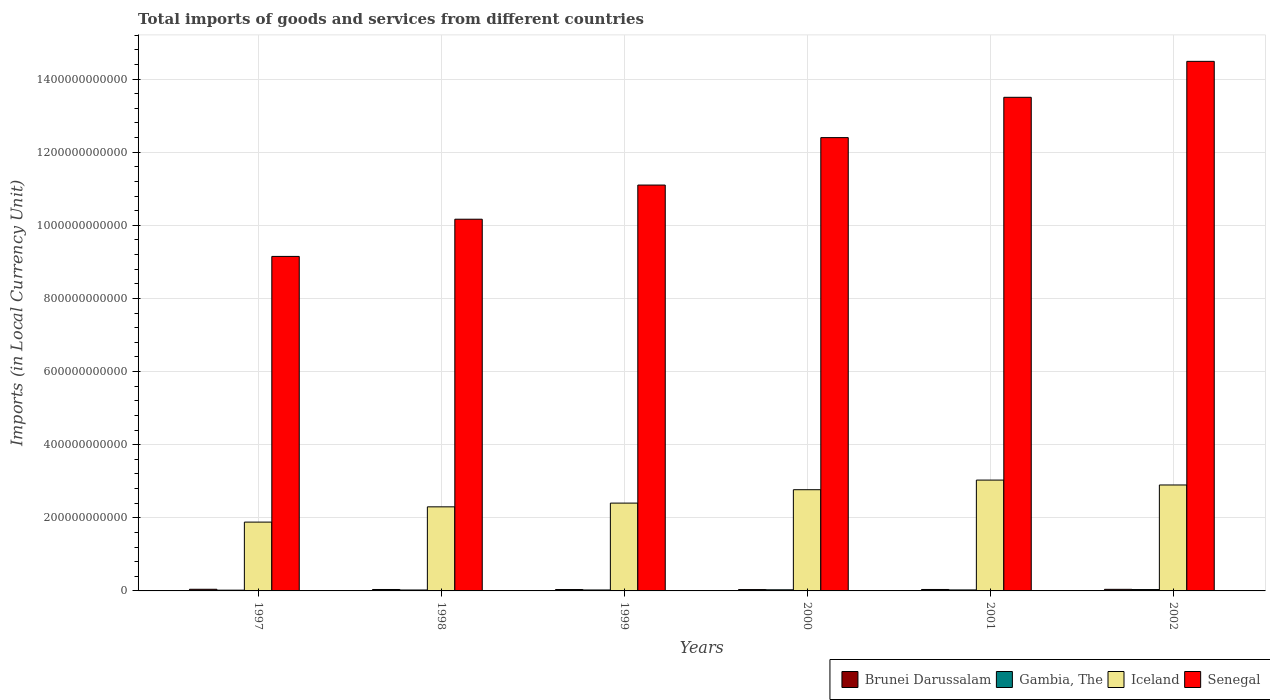How many groups of bars are there?
Your response must be concise. 6. Are the number of bars on each tick of the X-axis equal?
Make the answer very short. Yes. How many bars are there on the 6th tick from the right?
Your response must be concise. 4. In how many cases, is the number of bars for a given year not equal to the number of legend labels?
Your answer should be very brief. 0. What is the Amount of goods and services imports in Iceland in 2001?
Provide a short and direct response. 3.03e+11. Across all years, what is the maximum Amount of goods and services imports in Gambia, The?
Give a very brief answer. 3.74e+09. Across all years, what is the minimum Amount of goods and services imports in Iceland?
Keep it short and to the point. 1.88e+11. In which year was the Amount of goods and services imports in Senegal minimum?
Make the answer very short. 1997. What is the total Amount of goods and services imports in Senegal in the graph?
Your answer should be compact. 7.08e+12. What is the difference between the Amount of goods and services imports in Gambia, The in 2000 and that in 2001?
Your answer should be very brief. 3.52e+08. What is the difference between the Amount of goods and services imports in Brunei Darussalam in 2002 and the Amount of goods and services imports in Senegal in 1999?
Keep it short and to the point. -1.11e+12. What is the average Amount of goods and services imports in Gambia, The per year?
Make the answer very short. 2.79e+09. In the year 2000, what is the difference between the Amount of goods and services imports in Iceland and Amount of goods and services imports in Brunei Darussalam?
Give a very brief answer. 2.73e+11. In how many years, is the Amount of goods and services imports in Brunei Darussalam greater than 600000000000 LCU?
Your response must be concise. 0. What is the ratio of the Amount of goods and services imports in Gambia, The in 2000 to that in 2002?
Your answer should be very brief. 0.82. Is the Amount of goods and services imports in Senegal in 1999 less than that in 2001?
Your answer should be compact. Yes. What is the difference between the highest and the second highest Amount of goods and services imports in Iceland?
Give a very brief answer. 1.34e+1. What is the difference between the highest and the lowest Amount of goods and services imports in Senegal?
Your answer should be compact. 5.34e+11. In how many years, is the Amount of goods and services imports in Gambia, The greater than the average Amount of goods and services imports in Gambia, The taken over all years?
Provide a short and direct response. 2. Is the sum of the Amount of goods and services imports in Brunei Darussalam in 1997 and 2002 greater than the maximum Amount of goods and services imports in Gambia, The across all years?
Keep it short and to the point. Yes. Is it the case that in every year, the sum of the Amount of goods and services imports in Gambia, The and Amount of goods and services imports in Iceland is greater than the sum of Amount of goods and services imports in Senegal and Amount of goods and services imports in Brunei Darussalam?
Provide a succinct answer. Yes. What does the 2nd bar from the left in 1997 represents?
Give a very brief answer. Gambia, The. What does the 4th bar from the right in 1998 represents?
Keep it short and to the point. Brunei Darussalam. Is it the case that in every year, the sum of the Amount of goods and services imports in Senegal and Amount of goods and services imports in Iceland is greater than the Amount of goods and services imports in Brunei Darussalam?
Your answer should be compact. Yes. Are all the bars in the graph horizontal?
Keep it short and to the point. No. How many years are there in the graph?
Make the answer very short. 6. What is the difference between two consecutive major ticks on the Y-axis?
Make the answer very short. 2.00e+11. Are the values on the major ticks of Y-axis written in scientific E-notation?
Keep it short and to the point. No. Does the graph contain any zero values?
Ensure brevity in your answer.  No. Does the graph contain grids?
Offer a very short reply. Yes. Where does the legend appear in the graph?
Make the answer very short. Bottom right. How are the legend labels stacked?
Make the answer very short. Horizontal. What is the title of the graph?
Provide a short and direct response. Total imports of goods and services from different countries. What is the label or title of the Y-axis?
Ensure brevity in your answer.  Imports (in Local Currency Unit). What is the Imports (in Local Currency Unit) of Brunei Darussalam in 1997?
Give a very brief answer. 4.51e+09. What is the Imports (in Local Currency Unit) in Gambia, The in 1997?
Your answer should be very brief. 2.08e+09. What is the Imports (in Local Currency Unit) of Iceland in 1997?
Offer a terse response. 1.88e+11. What is the Imports (in Local Currency Unit) in Senegal in 1997?
Ensure brevity in your answer.  9.15e+11. What is the Imports (in Local Currency Unit) in Brunei Darussalam in 1998?
Offer a terse response. 3.89e+09. What is the Imports (in Local Currency Unit) of Gambia, The in 1998?
Keep it short and to the point. 2.55e+09. What is the Imports (in Local Currency Unit) of Iceland in 1998?
Provide a succinct answer. 2.30e+11. What is the Imports (in Local Currency Unit) of Senegal in 1998?
Ensure brevity in your answer.  1.02e+12. What is the Imports (in Local Currency Unit) of Brunei Darussalam in 1999?
Your response must be concise. 3.77e+09. What is the Imports (in Local Currency Unit) of Gambia, The in 1999?
Your answer should be very brief. 2.60e+09. What is the Imports (in Local Currency Unit) in Iceland in 1999?
Offer a terse response. 2.40e+11. What is the Imports (in Local Currency Unit) of Senegal in 1999?
Make the answer very short. 1.11e+12. What is the Imports (in Local Currency Unit) of Brunei Darussalam in 2000?
Ensure brevity in your answer.  3.71e+09. What is the Imports (in Local Currency Unit) of Gambia, The in 2000?
Your answer should be compact. 3.06e+09. What is the Imports (in Local Currency Unit) of Iceland in 2000?
Offer a very short reply. 2.77e+11. What is the Imports (in Local Currency Unit) in Senegal in 2000?
Offer a terse response. 1.24e+12. What is the Imports (in Local Currency Unit) of Brunei Darussalam in 2001?
Your answer should be compact. 3.93e+09. What is the Imports (in Local Currency Unit) of Gambia, The in 2001?
Your answer should be very brief. 2.71e+09. What is the Imports (in Local Currency Unit) in Iceland in 2001?
Ensure brevity in your answer.  3.03e+11. What is the Imports (in Local Currency Unit) in Senegal in 2001?
Offer a terse response. 1.35e+12. What is the Imports (in Local Currency Unit) of Brunei Darussalam in 2002?
Offer a very short reply. 4.36e+09. What is the Imports (in Local Currency Unit) in Gambia, The in 2002?
Your response must be concise. 3.74e+09. What is the Imports (in Local Currency Unit) of Iceland in 2002?
Your response must be concise. 2.90e+11. What is the Imports (in Local Currency Unit) of Senegal in 2002?
Provide a succinct answer. 1.45e+12. Across all years, what is the maximum Imports (in Local Currency Unit) of Brunei Darussalam?
Offer a terse response. 4.51e+09. Across all years, what is the maximum Imports (in Local Currency Unit) of Gambia, The?
Give a very brief answer. 3.74e+09. Across all years, what is the maximum Imports (in Local Currency Unit) in Iceland?
Provide a short and direct response. 3.03e+11. Across all years, what is the maximum Imports (in Local Currency Unit) of Senegal?
Provide a short and direct response. 1.45e+12. Across all years, what is the minimum Imports (in Local Currency Unit) in Brunei Darussalam?
Give a very brief answer. 3.71e+09. Across all years, what is the minimum Imports (in Local Currency Unit) in Gambia, The?
Give a very brief answer. 2.08e+09. Across all years, what is the minimum Imports (in Local Currency Unit) of Iceland?
Offer a very short reply. 1.88e+11. Across all years, what is the minimum Imports (in Local Currency Unit) of Senegal?
Provide a succinct answer. 9.15e+11. What is the total Imports (in Local Currency Unit) of Brunei Darussalam in the graph?
Provide a short and direct response. 2.42e+1. What is the total Imports (in Local Currency Unit) of Gambia, The in the graph?
Keep it short and to the point. 1.67e+1. What is the total Imports (in Local Currency Unit) of Iceland in the graph?
Your answer should be very brief. 1.53e+12. What is the total Imports (in Local Currency Unit) in Senegal in the graph?
Ensure brevity in your answer.  7.08e+12. What is the difference between the Imports (in Local Currency Unit) in Brunei Darussalam in 1997 and that in 1998?
Offer a very short reply. 6.22e+08. What is the difference between the Imports (in Local Currency Unit) of Gambia, The in 1997 and that in 1998?
Ensure brevity in your answer.  -4.74e+08. What is the difference between the Imports (in Local Currency Unit) of Iceland in 1997 and that in 1998?
Make the answer very short. -4.18e+1. What is the difference between the Imports (in Local Currency Unit) in Senegal in 1997 and that in 1998?
Provide a succinct answer. -1.02e+11. What is the difference between the Imports (in Local Currency Unit) in Brunei Darussalam in 1997 and that in 1999?
Give a very brief answer. 7.40e+08. What is the difference between the Imports (in Local Currency Unit) in Gambia, The in 1997 and that in 1999?
Provide a short and direct response. -5.20e+08. What is the difference between the Imports (in Local Currency Unit) in Iceland in 1997 and that in 1999?
Offer a terse response. -5.20e+1. What is the difference between the Imports (in Local Currency Unit) in Senegal in 1997 and that in 1999?
Offer a very short reply. -1.95e+11. What is the difference between the Imports (in Local Currency Unit) of Brunei Darussalam in 1997 and that in 2000?
Your answer should be very brief. 8.08e+08. What is the difference between the Imports (in Local Currency Unit) in Gambia, The in 1997 and that in 2000?
Your answer should be compact. -9.79e+08. What is the difference between the Imports (in Local Currency Unit) of Iceland in 1997 and that in 2000?
Your answer should be compact. -8.86e+1. What is the difference between the Imports (in Local Currency Unit) of Senegal in 1997 and that in 2000?
Ensure brevity in your answer.  -3.25e+11. What is the difference between the Imports (in Local Currency Unit) of Brunei Darussalam in 1997 and that in 2001?
Provide a short and direct response. 5.81e+08. What is the difference between the Imports (in Local Currency Unit) in Gambia, The in 1997 and that in 2001?
Provide a short and direct response. -6.27e+08. What is the difference between the Imports (in Local Currency Unit) of Iceland in 1997 and that in 2001?
Provide a succinct answer. -1.15e+11. What is the difference between the Imports (in Local Currency Unit) of Senegal in 1997 and that in 2001?
Your answer should be compact. -4.35e+11. What is the difference between the Imports (in Local Currency Unit) in Brunei Darussalam in 1997 and that in 2002?
Your answer should be compact. 1.59e+08. What is the difference between the Imports (in Local Currency Unit) of Gambia, The in 1997 and that in 2002?
Give a very brief answer. -1.66e+09. What is the difference between the Imports (in Local Currency Unit) in Iceland in 1997 and that in 2002?
Give a very brief answer. -1.02e+11. What is the difference between the Imports (in Local Currency Unit) in Senegal in 1997 and that in 2002?
Ensure brevity in your answer.  -5.34e+11. What is the difference between the Imports (in Local Currency Unit) of Brunei Darussalam in 1998 and that in 1999?
Make the answer very short. 1.18e+08. What is the difference between the Imports (in Local Currency Unit) in Gambia, The in 1998 and that in 1999?
Keep it short and to the point. -4.63e+07. What is the difference between the Imports (in Local Currency Unit) of Iceland in 1998 and that in 1999?
Offer a very short reply. -1.02e+1. What is the difference between the Imports (in Local Currency Unit) in Senegal in 1998 and that in 1999?
Give a very brief answer. -9.34e+1. What is the difference between the Imports (in Local Currency Unit) of Brunei Darussalam in 1998 and that in 2000?
Make the answer very short. 1.86e+08. What is the difference between the Imports (in Local Currency Unit) of Gambia, The in 1998 and that in 2000?
Your response must be concise. -5.05e+08. What is the difference between the Imports (in Local Currency Unit) in Iceland in 1998 and that in 2000?
Provide a short and direct response. -4.68e+1. What is the difference between the Imports (in Local Currency Unit) of Senegal in 1998 and that in 2000?
Offer a very short reply. -2.23e+11. What is the difference between the Imports (in Local Currency Unit) of Brunei Darussalam in 1998 and that in 2001?
Give a very brief answer. -4.13e+07. What is the difference between the Imports (in Local Currency Unit) of Gambia, The in 1998 and that in 2001?
Keep it short and to the point. -1.53e+08. What is the difference between the Imports (in Local Currency Unit) of Iceland in 1998 and that in 2001?
Give a very brief answer. -7.32e+1. What is the difference between the Imports (in Local Currency Unit) of Senegal in 1998 and that in 2001?
Give a very brief answer. -3.33e+11. What is the difference between the Imports (in Local Currency Unit) in Brunei Darussalam in 1998 and that in 2002?
Provide a succinct answer. -4.63e+08. What is the difference between the Imports (in Local Currency Unit) in Gambia, The in 1998 and that in 2002?
Offer a very short reply. -1.19e+09. What is the difference between the Imports (in Local Currency Unit) of Iceland in 1998 and that in 2002?
Your answer should be very brief. -5.98e+1. What is the difference between the Imports (in Local Currency Unit) in Senegal in 1998 and that in 2002?
Ensure brevity in your answer.  -4.32e+11. What is the difference between the Imports (in Local Currency Unit) in Brunei Darussalam in 1999 and that in 2000?
Give a very brief answer. 6.83e+07. What is the difference between the Imports (in Local Currency Unit) in Gambia, The in 1999 and that in 2000?
Your response must be concise. -4.59e+08. What is the difference between the Imports (in Local Currency Unit) in Iceland in 1999 and that in 2000?
Your answer should be very brief. -3.66e+1. What is the difference between the Imports (in Local Currency Unit) in Senegal in 1999 and that in 2000?
Give a very brief answer. -1.30e+11. What is the difference between the Imports (in Local Currency Unit) of Brunei Darussalam in 1999 and that in 2001?
Give a very brief answer. -1.59e+08. What is the difference between the Imports (in Local Currency Unit) in Gambia, The in 1999 and that in 2001?
Make the answer very short. -1.07e+08. What is the difference between the Imports (in Local Currency Unit) in Iceland in 1999 and that in 2001?
Offer a very short reply. -6.30e+1. What is the difference between the Imports (in Local Currency Unit) in Senegal in 1999 and that in 2001?
Your answer should be very brief. -2.40e+11. What is the difference between the Imports (in Local Currency Unit) of Brunei Darussalam in 1999 and that in 2002?
Make the answer very short. -5.81e+08. What is the difference between the Imports (in Local Currency Unit) in Gambia, The in 1999 and that in 2002?
Offer a very short reply. -1.14e+09. What is the difference between the Imports (in Local Currency Unit) in Iceland in 1999 and that in 2002?
Your answer should be compact. -4.95e+1. What is the difference between the Imports (in Local Currency Unit) in Senegal in 1999 and that in 2002?
Give a very brief answer. -3.38e+11. What is the difference between the Imports (in Local Currency Unit) of Brunei Darussalam in 2000 and that in 2001?
Your response must be concise. -2.28e+08. What is the difference between the Imports (in Local Currency Unit) of Gambia, The in 2000 and that in 2001?
Your response must be concise. 3.52e+08. What is the difference between the Imports (in Local Currency Unit) in Iceland in 2000 and that in 2001?
Your answer should be compact. -2.64e+1. What is the difference between the Imports (in Local Currency Unit) of Senegal in 2000 and that in 2001?
Your answer should be very brief. -1.10e+11. What is the difference between the Imports (in Local Currency Unit) in Brunei Darussalam in 2000 and that in 2002?
Give a very brief answer. -6.50e+08. What is the difference between the Imports (in Local Currency Unit) in Gambia, The in 2000 and that in 2002?
Give a very brief answer. -6.82e+08. What is the difference between the Imports (in Local Currency Unit) in Iceland in 2000 and that in 2002?
Offer a terse response. -1.29e+1. What is the difference between the Imports (in Local Currency Unit) in Senegal in 2000 and that in 2002?
Your response must be concise. -2.09e+11. What is the difference between the Imports (in Local Currency Unit) of Brunei Darussalam in 2001 and that in 2002?
Your answer should be very brief. -4.22e+08. What is the difference between the Imports (in Local Currency Unit) in Gambia, The in 2001 and that in 2002?
Ensure brevity in your answer.  -1.03e+09. What is the difference between the Imports (in Local Currency Unit) in Iceland in 2001 and that in 2002?
Your response must be concise. 1.34e+1. What is the difference between the Imports (in Local Currency Unit) in Senegal in 2001 and that in 2002?
Provide a succinct answer. -9.83e+1. What is the difference between the Imports (in Local Currency Unit) in Brunei Darussalam in 1997 and the Imports (in Local Currency Unit) in Gambia, The in 1998?
Offer a terse response. 1.96e+09. What is the difference between the Imports (in Local Currency Unit) of Brunei Darussalam in 1997 and the Imports (in Local Currency Unit) of Iceland in 1998?
Your answer should be very brief. -2.25e+11. What is the difference between the Imports (in Local Currency Unit) in Brunei Darussalam in 1997 and the Imports (in Local Currency Unit) in Senegal in 1998?
Make the answer very short. -1.01e+12. What is the difference between the Imports (in Local Currency Unit) in Gambia, The in 1997 and the Imports (in Local Currency Unit) in Iceland in 1998?
Provide a succinct answer. -2.28e+11. What is the difference between the Imports (in Local Currency Unit) in Gambia, The in 1997 and the Imports (in Local Currency Unit) in Senegal in 1998?
Offer a terse response. -1.01e+12. What is the difference between the Imports (in Local Currency Unit) in Iceland in 1997 and the Imports (in Local Currency Unit) in Senegal in 1998?
Provide a succinct answer. -8.29e+11. What is the difference between the Imports (in Local Currency Unit) of Brunei Darussalam in 1997 and the Imports (in Local Currency Unit) of Gambia, The in 1999?
Keep it short and to the point. 1.91e+09. What is the difference between the Imports (in Local Currency Unit) of Brunei Darussalam in 1997 and the Imports (in Local Currency Unit) of Iceland in 1999?
Keep it short and to the point. -2.36e+11. What is the difference between the Imports (in Local Currency Unit) of Brunei Darussalam in 1997 and the Imports (in Local Currency Unit) of Senegal in 1999?
Make the answer very short. -1.11e+12. What is the difference between the Imports (in Local Currency Unit) in Gambia, The in 1997 and the Imports (in Local Currency Unit) in Iceland in 1999?
Ensure brevity in your answer.  -2.38e+11. What is the difference between the Imports (in Local Currency Unit) of Gambia, The in 1997 and the Imports (in Local Currency Unit) of Senegal in 1999?
Ensure brevity in your answer.  -1.11e+12. What is the difference between the Imports (in Local Currency Unit) of Iceland in 1997 and the Imports (in Local Currency Unit) of Senegal in 1999?
Make the answer very short. -9.22e+11. What is the difference between the Imports (in Local Currency Unit) in Brunei Darussalam in 1997 and the Imports (in Local Currency Unit) in Gambia, The in 2000?
Ensure brevity in your answer.  1.45e+09. What is the difference between the Imports (in Local Currency Unit) in Brunei Darussalam in 1997 and the Imports (in Local Currency Unit) in Iceland in 2000?
Ensure brevity in your answer.  -2.72e+11. What is the difference between the Imports (in Local Currency Unit) in Brunei Darussalam in 1997 and the Imports (in Local Currency Unit) in Senegal in 2000?
Make the answer very short. -1.24e+12. What is the difference between the Imports (in Local Currency Unit) in Gambia, The in 1997 and the Imports (in Local Currency Unit) in Iceland in 2000?
Keep it short and to the point. -2.75e+11. What is the difference between the Imports (in Local Currency Unit) in Gambia, The in 1997 and the Imports (in Local Currency Unit) in Senegal in 2000?
Give a very brief answer. -1.24e+12. What is the difference between the Imports (in Local Currency Unit) in Iceland in 1997 and the Imports (in Local Currency Unit) in Senegal in 2000?
Your response must be concise. -1.05e+12. What is the difference between the Imports (in Local Currency Unit) in Brunei Darussalam in 1997 and the Imports (in Local Currency Unit) in Gambia, The in 2001?
Make the answer very short. 1.81e+09. What is the difference between the Imports (in Local Currency Unit) in Brunei Darussalam in 1997 and the Imports (in Local Currency Unit) in Iceland in 2001?
Make the answer very short. -2.99e+11. What is the difference between the Imports (in Local Currency Unit) of Brunei Darussalam in 1997 and the Imports (in Local Currency Unit) of Senegal in 2001?
Make the answer very short. -1.35e+12. What is the difference between the Imports (in Local Currency Unit) of Gambia, The in 1997 and the Imports (in Local Currency Unit) of Iceland in 2001?
Ensure brevity in your answer.  -3.01e+11. What is the difference between the Imports (in Local Currency Unit) of Gambia, The in 1997 and the Imports (in Local Currency Unit) of Senegal in 2001?
Your answer should be compact. -1.35e+12. What is the difference between the Imports (in Local Currency Unit) of Iceland in 1997 and the Imports (in Local Currency Unit) of Senegal in 2001?
Provide a short and direct response. -1.16e+12. What is the difference between the Imports (in Local Currency Unit) in Brunei Darussalam in 1997 and the Imports (in Local Currency Unit) in Gambia, The in 2002?
Provide a short and direct response. 7.73e+08. What is the difference between the Imports (in Local Currency Unit) of Brunei Darussalam in 1997 and the Imports (in Local Currency Unit) of Iceland in 2002?
Provide a short and direct response. -2.85e+11. What is the difference between the Imports (in Local Currency Unit) in Brunei Darussalam in 1997 and the Imports (in Local Currency Unit) in Senegal in 2002?
Ensure brevity in your answer.  -1.44e+12. What is the difference between the Imports (in Local Currency Unit) of Gambia, The in 1997 and the Imports (in Local Currency Unit) of Iceland in 2002?
Provide a succinct answer. -2.88e+11. What is the difference between the Imports (in Local Currency Unit) of Gambia, The in 1997 and the Imports (in Local Currency Unit) of Senegal in 2002?
Your answer should be compact. -1.45e+12. What is the difference between the Imports (in Local Currency Unit) of Iceland in 1997 and the Imports (in Local Currency Unit) of Senegal in 2002?
Provide a short and direct response. -1.26e+12. What is the difference between the Imports (in Local Currency Unit) of Brunei Darussalam in 1998 and the Imports (in Local Currency Unit) of Gambia, The in 1999?
Keep it short and to the point. 1.29e+09. What is the difference between the Imports (in Local Currency Unit) of Brunei Darussalam in 1998 and the Imports (in Local Currency Unit) of Iceland in 1999?
Keep it short and to the point. -2.36e+11. What is the difference between the Imports (in Local Currency Unit) of Brunei Darussalam in 1998 and the Imports (in Local Currency Unit) of Senegal in 1999?
Make the answer very short. -1.11e+12. What is the difference between the Imports (in Local Currency Unit) of Gambia, The in 1998 and the Imports (in Local Currency Unit) of Iceland in 1999?
Give a very brief answer. -2.38e+11. What is the difference between the Imports (in Local Currency Unit) in Gambia, The in 1998 and the Imports (in Local Currency Unit) in Senegal in 1999?
Your response must be concise. -1.11e+12. What is the difference between the Imports (in Local Currency Unit) of Iceland in 1998 and the Imports (in Local Currency Unit) of Senegal in 1999?
Your answer should be compact. -8.80e+11. What is the difference between the Imports (in Local Currency Unit) in Brunei Darussalam in 1998 and the Imports (in Local Currency Unit) in Gambia, The in 2000?
Provide a succinct answer. 8.32e+08. What is the difference between the Imports (in Local Currency Unit) of Brunei Darussalam in 1998 and the Imports (in Local Currency Unit) of Iceland in 2000?
Offer a terse response. -2.73e+11. What is the difference between the Imports (in Local Currency Unit) of Brunei Darussalam in 1998 and the Imports (in Local Currency Unit) of Senegal in 2000?
Offer a terse response. -1.24e+12. What is the difference between the Imports (in Local Currency Unit) of Gambia, The in 1998 and the Imports (in Local Currency Unit) of Iceland in 2000?
Your answer should be very brief. -2.74e+11. What is the difference between the Imports (in Local Currency Unit) of Gambia, The in 1998 and the Imports (in Local Currency Unit) of Senegal in 2000?
Provide a short and direct response. -1.24e+12. What is the difference between the Imports (in Local Currency Unit) of Iceland in 1998 and the Imports (in Local Currency Unit) of Senegal in 2000?
Your answer should be compact. -1.01e+12. What is the difference between the Imports (in Local Currency Unit) of Brunei Darussalam in 1998 and the Imports (in Local Currency Unit) of Gambia, The in 2001?
Your response must be concise. 1.18e+09. What is the difference between the Imports (in Local Currency Unit) in Brunei Darussalam in 1998 and the Imports (in Local Currency Unit) in Iceland in 2001?
Offer a terse response. -2.99e+11. What is the difference between the Imports (in Local Currency Unit) in Brunei Darussalam in 1998 and the Imports (in Local Currency Unit) in Senegal in 2001?
Offer a terse response. -1.35e+12. What is the difference between the Imports (in Local Currency Unit) of Gambia, The in 1998 and the Imports (in Local Currency Unit) of Iceland in 2001?
Make the answer very short. -3.01e+11. What is the difference between the Imports (in Local Currency Unit) of Gambia, The in 1998 and the Imports (in Local Currency Unit) of Senegal in 2001?
Your answer should be very brief. -1.35e+12. What is the difference between the Imports (in Local Currency Unit) of Iceland in 1998 and the Imports (in Local Currency Unit) of Senegal in 2001?
Ensure brevity in your answer.  -1.12e+12. What is the difference between the Imports (in Local Currency Unit) in Brunei Darussalam in 1998 and the Imports (in Local Currency Unit) in Gambia, The in 2002?
Your response must be concise. 1.51e+08. What is the difference between the Imports (in Local Currency Unit) of Brunei Darussalam in 1998 and the Imports (in Local Currency Unit) of Iceland in 2002?
Offer a terse response. -2.86e+11. What is the difference between the Imports (in Local Currency Unit) in Brunei Darussalam in 1998 and the Imports (in Local Currency Unit) in Senegal in 2002?
Offer a terse response. -1.44e+12. What is the difference between the Imports (in Local Currency Unit) in Gambia, The in 1998 and the Imports (in Local Currency Unit) in Iceland in 2002?
Offer a very short reply. -2.87e+11. What is the difference between the Imports (in Local Currency Unit) in Gambia, The in 1998 and the Imports (in Local Currency Unit) in Senegal in 2002?
Your response must be concise. -1.45e+12. What is the difference between the Imports (in Local Currency Unit) in Iceland in 1998 and the Imports (in Local Currency Unit) in Senegal in 2002?
Keep it short and to the point. -1.22e+12. What is the difference between the Imports (in Local Currency Unit) in Brunei Darussalam in 1999 and the Imports (in Local Currency Unit) in Gambia, The in 2000?
Offer a very short reply. 7.14e+08. What is the difference between the Imports (in Local Currency Unit) in Brunei Darussalam in 1999 and the Imports (in Local Currency Unit) in Iceland in 2000?
Provide a short and direct response. -2.73e+11. What is the difference between the Imports (in Local Currency Unit) in Brunei Darussalam in 1999 and the Imports (in Local Currency Unit) in Senegal in 2000?
Keep it short and to the point. -1.24e+12. What is the difference between the Imports (in Local Currency Unit) in Gambia, The in 1999 and the Imports (in Local Currency Unit) in Iceland in 2000?
Make the answer very short. -2.74e+11. What is the difference between the Imports (in Local Currency Unit) in Gambia, The in 1999 and the Imports (in Local Currency Unit) in Senegal in 2000?
Keep it short and to the point. -1.24e+12. What is the difference between the Imports (in Local Currency Unit) in Iceland in 1999 and the Imports (in Local Currency Unit) in Senegal in 2000?
Keep it short and to the point. -1.00e+12. What is the difference between the Imports (in Local Currency Unit) of Brunei Darussalam in 1999 and the Imports (in Local Currency Unit) of Gambia, The in 2001?
Offer a terse response. 1.07e+09. What is the difference between the Imports (in Local Currency Unit) in Brunei Darussalam in 1999 and the Imports (in Local Currency Unit) in Iceland in 2001?
Your answer should be very brief. -2.99e+11. What is the difference between the Imports (in Local Currency Unit) of Brunei Darussalam in 1999 and the Imports (in Local Currency Unit) of Senegal in 2001?
Your response must be concise. -1.35e+12. What is the difference between the Imports (in Local Currency Unit) of Gambia, The in 1999 and the Imports (in Local Currency Unit) of Iceland in 2001?
Offer a very short reply. -3.01e+11. What is the difference between the Imports (in Local Currency Unit) of Gambia, The in 1999 and the Imports (in Local Currency Unit) of Senegal in 2001?
Keep it short and to the point. -1.35e+12. What is the difference between the Imports (in Local Currency Unit) in Iceland in 1999 and the Imports (in Local Currency Unit) in Senegal in 2001?
Your response must be concise. -1.11e+12. What is the difference between the Imports (in Local Currency Unit) in Brunei Darussalam in 1999 and the Imports (in Local Currency Unit) in Gambia, The in 2002?
Make the answer very short. 3.26e+07. What is the difference between the Imports (in Local Currency Unit) in Brunei Darussalam in 1999 and the Imports (in Local Currency Unit) in Iceland in 2002?
Provide a short and direct response. -2.86e+11. What is the difference between the Imports (in Local Currency Unit) of Brunei Darussalam in 1999 and the Imports (in Local Currency Unit) of Senegal in 2002?
Keep it short and to the point. -1.44e+12. What is the difference between the Imports (in Local Currency Unit) in Gambia, The in 1999 and the Imports (in Local Currency Unit) in Iceland in 2002?
Keep it short and to the point. -2.87e+11. What is the difference between the Imports (in Local Currency Unit) in Gambia, The in 1999 and the Imports (in Local Currency Unit) in Senegal in 2002?
Keep it short and to the point. -1.45e+12. What is the difference between the Imports (in Local Currency Unit) of Iceland in 1999 and the Imports (in Local Currency Unit) of Senegal in 2002?
Provide a succinct answer. -1.21e+12. What is the difference between the Imports (in Local Currency Unit) in Brunei Darussalam in 2000 and the Imports (in Local Currency Unit) in Gambia, The in 2001?
Give a very brief answer. 9.98e+08. What is the difference between the Imports (in Local Currency Unit) in Brunei Darussalam in 2000 and the Imports (in Local Currency Unit) in Iceland in 2001?
Ensure brevity in your answer.  -2.99e+11. What is the difference between the Imports (in Local Currency Unit) in Brunei Darussalam in 2000 and the Imports (in Local Currency Unit) in Senegal in 2001?
Keep it short and to the point. -1.35e+12. What is the difference between the Imports (in Local Currency Unit) of Gambia, The in 2000 and the Imports (in Local Currency Unit) of Iceland in 2001?
Make the answer very short. -3.00e+11. What is the difference between the Imports (in Local Currency Unit) of Gambia, The in 2000 and the Imports (in Local Currency Unit) of Senegal in 2001?
Give a very brief answer. -1.35e+12. What is the difference between the Imports (in Local Currency Unit) in Iceland in 2000 and the Imports (in Local Currency Unit) in Senegal in 2001?
Your answer should be compact. -1.07e+12. What is the difference between the Imports (in Local Currency Unit) of Brunei Darussalam in 2000 and the Imports (in Local Currency Unit) of Gambia, The in 2002?
Give a very brief answer. -3.58e+07. What is the difference between the Imports (in Local Currency Unit) in Brunei Darussalam in 2000 and the Imports (in Local Currency Unit) in Iceland in 2002?
Offer a very short reply. -2.86e+11. What is the difference between the Imports (in Local Currency Unit) of Brunei Darussalam in 2000 and the Imports (in Local Currency Unit) of Senegal in 2002?
Your answer should be very brief. -1.44e+12. What is the difference between the Imports (in Local Currency Unit) of Gambia, The in 2000 and the Imports (in Local Currency Unit) of Iceland in 2002?
Give a very brief answer. -2.87e+11. What is the difference between the Imports (in Local Currency Unit) in Gambia, The in 2000 and the Imports (in Local Currency Unit) in Senegal in 2002?
Keep it short and to the point. -1.45e+12. What is the difference between the Imports (in Local Currency Unit) in Iceland in 2000 and the Imports (in Local Currency Unit) in Senegal in 2002?
Keep it short and to the point. -1.17e+12. What is the difference between the Imports (in Local Currency Unit) in Brunei Darussalam in 2001 and the Imports (in Local Currency Unit) in Gambia, The in 2002?
Provide a succinct answer. 1.92e+08. What is the difference between the Imports (in Local Currency Unit) of Brunei Darussalam in 2001 and the Imports (in Local Currency Unit) of Iceland in 2002?
Offer a very short reply. -2.86e+11. What is the difference between the Imports (in Local Currency Unit) of Brunei Darussalam in 2001 and the Imports (in Local Currency Unit) of Senegal in 2002?
Provide a succinct answer. -1.44e+12. What is the difference between the Imports (in Local Currency Unit) of Gambia, The in 2001 and the Imports (in Local Currency Unit) of Iceland in 2002?
Provide a short and direct response. -2.87e+11. What is the difference between the Imports (in Local Currency Unit) of Gambia, The in 2001 and the Imports (in Local Currency Unit) of Senegal in 2002?
Make the answer very short. -1.45e+12. What is the difference between the Imports (in Local Currency Unit) of Iceland in 2001 and the Imports (in Local Currency Unit) of Senegal in 2002?
Make the answer very short. -1.15e+12. What is the average Imports (in Local Currency Unit) in Brunei Darussalam per year?
Give a very brief answer. 4.03e+09. What is the average Imports (in Local Currency Unit) in Gambia, The per year?
Keep it short and to the point. 2.79e+09. What is the average Imports (in Local Currency Unit) in Iceland per year?
Your response must be concise. 2.55e+11. What is the average Imports (in Local Currency Unit) of Senegal per year?
Provide a short and direct response. 1.18e+12. In the year 1997, what is the difference between the Imports (in Local Currency Unit) in Brunei Darussalam and Imports (in Local Currency Unit) in Gambia, The?
Offer a terse response. 2.43e+09. In the year 1997, what is the difference between the Imports (in Local Currency Unit) of Brunei Darussalam and Imports (in Local Currency Unit) of Iceland?
Ensure brevity in your answer.  -1.84e+11. In the year 1997, what is the difference between the Imports (in Local Currency Unit) in Brunei Darussalam and Imports (in Local Currency Unit) in Senegal?
Ensure brevity in your answer.  -9.11e+11. In the year 1997, what is the difference between the Imports (in Local Currency Unit) of Gambia, The and Imports (in Local Currency Unit) of Iceland?
Make the answer very short. -1.86e+11. In the year 1997, what is the difference between the Imports (in Local Currency Unit) in Gambia, The and Imports (in Local Currency Unit) in Senegal?
Ensure brevity in your answer.  -9.13e+11. In the year 1997, what is the difference between the Imports (in Local Currency Unit) in Iceland and Imports (in Local Currency Unit) in Senegal?
Provide a short and direct response. -7.27e+11. In the year 1998, what is the difference between the Imports (in Local Currency Unit) in Brunei Darussalam and Imports (in Local Currency Unit) in Gambia, The?
Offer a terse response. 1.34e+09. In the year 1998, what is the difference between the Imports (in Local Currency Unit) of Brunei Darussalam and Imports (in Local Currency Unit) of Iceland?
Keep it short and to the point. -2.26e+11. In the year 1998, what is the difference between the Imports (in Local Currency Unit) in Brunei Darussalam and Imports (in Local Currency Unit) in Senegal?
Ensure brevity in your answer.  -1.01e+12. In the year 1998, what is the difference between the Imports (in Local Currency Unit) of Gambia, The and Imports (in Local Currency Unit) of Iceland?
Give a very brief answer. -2.27e+11. In the year 1998, what is the difference between the Imports (in Local Currency Unit) in Gambia, The and Imports (in Local Currency Unit) in Senegal?
Your answer should be very brief. -1.01e+12. In the year 1998, what is the difference between the Imports (in Local Currency Unit) of Iceland and Imports (in Local Currency Unit) of Senegal?
Provide a short and direct response. -7.87e+11. In the year 1999, what is the difference between the Imports (in Local Currency Unit) of Brunei Darussalam and Imports (in Local Currency Unit) of Gambia, The?
Your response must be concise. 1.17e+09. In the year 1999, what is the difference between the Imports (in Local Currency Unit) of Brunei Darussalam and Imports (in Local Currency Unit) of Iceland?
Keep it short and to the point. -2.36e+11. In the year 1999, what is the difference between the Imports (in Local Currency Unit) of Brunei Darussalam and Imports (in Local Currency Unit) of Senegal?
Offer a very short reply. -1.11e+12. In the year 1999, what is the difference between the Imports (in Local Currency Unit) in Gambia, The and Imports (in Local Currency Unit) in Iceland?
Keep it short and to the point. -2.38e+11. In the year 1999, what is the difference between the Imports (in Local Currency Unit) in Gambia, The and Imports (in Local Currency Unit) in Senegal?
Provide a succinct answer. -1.11e+12. In the year 1999, what is the difference between the Imports (in Local Currency Unit) in Iceland and Imports (in Local Currency Unit) in Senegal?
Your answer should be compact. -8.70e+11. In the year 2000, what is the difference between the Imports (in Local Currency Unit) of Brunei Darussalam and Imports (in Local Currency Unit) of Gambia, The?
Your answer should be very brief. 6.46e+08. In the year 2000, what is the difference between the Imports (in Local Currency Unit) in Brunei Darussalam and Imports (in Local Currency Unit) in Iceland?
Offer a terse response. -2.73e+11. In the year 2000, what is the difference between the Imports (in Local Currency Unit) in Brunei Darussalam and Imports (in Local Currency Unit) in Senegal?
Give a very brief answer. -1.24e+12. In the year 2000, what is the difference between the Imports (in Local Currency Unit) in Gambia, The and Imports (in Local Currency Unit) in Iceland?
Offer a terse response. -2.74e+11. In the year 2000, what is the difference between the Imports (in Local Currency Unit) in Gambia, The and Imports (in Local Currency Unit) in Senegal?
Offer a very short reply. -1.24e+12. In the year 2000, what is the difference between the Imports (in Local Currency Unit) of Iceland and Imports (in Local Currency Unit) of Senegal?
Ensure brevity in your answer.  -9.63e+11. In the year 2001, what is the difference between the Imports (in Local Currency Unit) in Brunei Darussalam and Imports (in Local Currency Unit) in Gambia, The?
Provide a short and direct response. 1.23e+09. In the year 2001, what is the difference between the Imports (in Local Currency Unit) in Brunei Darussalam and Imports (in Local Currency Unit) in Iceland?
Offer a terse response. -2.99e+11. In the year 2001, what is the difference between the Imports (in Local Currency Unit) in Brunei Darussalam and Imports (in Local Currency Unit) in Senegal?
Provide a short and direct response. -1.35e+12. In the year 2001, what is the difference between the Imports (in Local Currency Unit) of Gambia, The and Imports (in Local Currency Unit) of Iceland?
Your answer should be very brief. -3.00e+11. In the year 2001, what is the difference between the Imports (in Local Currency Unit) of Gambia, The and Imports (in Local Currency Unit) of Senegal?
Keep it short and to the point. -1.35e+12. In the year 2001, what is the difference between the Imports (in Local Currency Unit) in Iceland and Imports (in Local Currency Unit) in Senegal?
Provide a short and direct response. -1.05e+12. In the year 2002, what is the difference between the Imports (in Local Currency Unit) of Brunei Darussalam and Imports (in Local Currency Unit) of Gambia, The?
Your answer should be compact. 6.14e+08. In the year 2002, what is the difference between the Imports (in Local Currency Unit) in Brunei Darussalam and Imports (in Local Currency Unit) in Iceland?
Keep it short and to the point. -2.85e+11. In the year 2002, what is the difference between the Imports (in Local Currency Unit) of Brunei Darussalam and Imports (in Local Currency Unit) of Senegal?
Make the answer very short. -1.44e+12. In the year 2002, what is the difference between the Imports (in Local Currency Unit) of Gambia, The and Imports (in Local Currency Unit) of Iceland?
Keep it short and to the point. -2.86e+11. In the year 2002, what is the difference between the Imports (in Local Currency Unit) in Gambia, The and Imports (in Local Currency Unit) in Senegal?
Keep it short and to the point. -1.44e+12. In the year 2002, what is the difference between the Imports (in Local Currency Unit) of Iceland and Imports (in Local Currency Unit) of Senegal?
Your answer should be compact. -1.16e+12. What is the ratio of the Imports (in Local Currency Unit) of Brunei Darussalam in 1997 to that in 1998?
Ensure brevity in your answer.  1.16. What is the ratio of the Imports (in Local Currency Unit) of Gambia, The in 1997 to that in 1998?
Give a very brief answer. 0.81. What is the ratio of the Imports (in Local Currency Unit) in Iceland in 1997 to that in 1998?
Offer a terse response. 0.82. What is the ratio of the Imports (in Local Currency Unit) in Senegal in 1997 to that in 1998?
Your answer should be very brief. 0.9. What is the ratio of the Imports (in Local Currency Unit) of Brunei Darussalam in 1997 to that in 1999?
Keep it short and to the point. 1.2. What is the ratio of the Imports (in Local Currency Unit) of Iceland in 1997 to that in 1999?
Your response must be concise. 0.78. What is the ratio of the Imports (in Local Currency Unit) of Senegal in 1997 to that in 1999?
Provide a succinct answer. 0.82. What is the ratio of the Imports (in Local Currency Unit) of Brunei Darussalam in 1997 to that in 2000?
Offer a terse response. 1.22. What is the ratio of the Imports (in Local Currency Unit) in Gambia, The in 1997 to that in 2000?
Give a very brief answer. 0.68. What is the ratio of the Imports (in Local Currency Unit) in Iceland in 1997 to that in 2000?
Make the answer very short. 0.68. What is the ratio of the Imports (in Local Currency Unit) of Senegal in 1997 to that in 2000?
Keep it short and to the point. 0.74. What is the ratio of the Imports (in Local Currency Unit) in Brunei Darussalam in 1997 to that in 2001?
Make the answer very short. 1.15. What is the ratio of the Imports (in Local Currency Unit) of Gambia, The in 1997 to that in 2001?
Ensure brevity in your answer.  0.77. What is the ratio of the Imports (in Local Currency Unit) of Iceland in 1997 to that in 2001?
Offer a terse response. 0.62. What is the ratio of the Imports (in Local Currency Unit) of Senegal in 1997 to that in 2001?
Offer a terse response. 0.68. What is the ratio of the Imports (in Local Currency Unit) of Brunei Darussalam in 1997 to that in 2002?
Your response must be concise. 1.04. What is the ratio of the Imports (in Local Currency Unit) in Gambia, The in 1997 to that in 2002?
Provide a succinct answer. 0.56. What is the ratio of the Imports (in Local Currency Unit) in Iceland in 1997 to that in 2002?
Offer a very short reply. 0.65. What is the ratio of the Imports (in Local Currency Unit) of Senegal in 1997 to that in 2002?
Give a very brief answer. 0.63. What is the ratio of the Imports (in Local Currency Unit) in Brunei Darussalam in 1998 to that in 1999?
Provide a succinct answer. 1.03. What is the ratio of the Imports (in Local Currency Unit) in Gambia, The in 1998 to that in 1999?
Offer a very short reply. 0.98. What is the ratio of the Imports (in Local Currency Unit) in Iceland in 1998 to that in 1999?
Your answer should be very brief. 0.96. What is the ratio of the Imports (in Local Currency Unit) in Senegal in 1998 to that in 1999?
Provide a succinct answer. 0.92. What is the ratio of the Imports (in Local Currency Unit) of Brunei Darussalam in 1998 to that in 2000?
Provide a succinct answer. 1.05. What is the ratio of the Imports (in Local Currency Unit) in Gambia, The in 1998 to that in 2000?
Keep it short and to the point. 0.83. What is the ratio of the Imports (in Local Currency Unit) of Iceland in 1998 to that in 2000?
Offer a very short reply. 0.83. What is the ratio of the Imports (in Local Currency Unit) of Senegal in 1998 to that in 2000?
Your answer should be compact. 0.82. What is the ratio of the Imports (in Local Currency Unit) in Brunei Darussalam in 1998 to that in 2001?
Ensure brevity in your answer.  0.99. What is the ratio of the Imports (in Local Currency Unit) of Gambia, The in 1998 to that in 2001?
Offer a very short reply. 0.94. What is the ratio of the Imports (in Local Currency Unit) in Iceland in 1998 to that in 2001?
Keep it short and to the point. 0.76. What is the ratio of the Imports (in Local Currency Unit) in Senegal in 1998 to that in 2001?
Provide a short and direct response. 0.75. What is the ratio of the Imports (in Local Currency Unit) of Brunei Darussalam in 1998 to that in 2002?
Give a very brief answer. 0.89. What is the ratio of the Imports (in Local Currency Unit) in Gambia, The in 1998 to that in 2002?
Ensure brevity in your answer.  0.68. What is the ratio of the Imports (in Local Currency Unit) in Iceland in 1998 to that in 2002?
Ensure brevity in your answer.  0.79. What is the ratio of the Imports (in Local Currency Unit) of Senegal in 1998 to that in 2002?
Make the answer very short. 0.7. What is the ratio of the Imports (in Local Currency Unit) in Brunei Darussalam in 1999 to that in 2000?
Provide a short and direct response. 1.02. What is the ratio of the Imports (in Local Currency Unit) in Gambia, The in 1999 to that in 2000?
Give a very brief answer. 0.85. What is the ratio of the Imports (in Local Currency Unit) of Iceland in 1999 to that in 2000?
Provide a succinct answer. 0.87. What is the ratio of the Imports (in Local Currency Unit) in Senegal in 1999 to that in 2000?
Offer a very short reply. 0.9. What is the ratio of the Imports (in Local Currency Unit) in Brunei Darussalam in 1999 to that in 2001?
Make the answer very short. 0.96. What is the ratio of the Imports (in Local Currency Unit) of Gambia, The in 1999 to that in 2001?
Your answer should be very brief. 0.96. What is the ratio of the Imports (in Local Currency Unit) of Iceland in 1999 to that in 2001?
Your response must be concise. 0.79. What is the ratio of the Imports (in Local Currency Unit) in Senegal in 1999 to that in 2001?
Ensure brevity in your answer.  0.82. What is the ratio of the Imports (in Local Currency Unit) in Brunei Darussalam in 1999 to that in 2002?
Ensure brevity in your answer.  0.87. What is the ratio of the Imports (in Local Currency Unit) of Gambia, The in 1999 to that in 2002?
Provide a short and direct response. 0.7. What is the ratio of the Imports (in Local Currency Unit) in Iceland in 1999 to that in 2002?
Give a very brief answer. 0.83. What is the ratio of the Imports (in Local Currency Unit) of Senegal in 1999 to that in 2002?
Keep it short and to the point. 0.77. What is the ratio of the Imports (in Local Currency Unit) in Brunei Darussalam in 2000 to that in 2001?
Your response must be concise. 0.94. What is the ratio of the Imports (in Local Currency Unit) in Gambia, The in 2000 to that in 2001?
Your response must be concise. 1.13. What is the ratio of the Imports (in Local Currency Unit) of Iceland in 2000 to that in 2001?
Keep it short and to the point. 0.91. What is the ratio of the Imports (in Local Currency Unit) in Senegal in 2000 to that in 2001?
Give a very brief answer. 0.92. What is the ratio of the Imports (in Local Currency Unit) in Brunei Darussalam in 2000 to that in 2002?
Offer a terse response. 0.85. What is the ratio of the Imports (in Local Currency Unit) of Gambia, The in 2000 to that in 2002?
Make the answer very short. 0.82. What is the ratio of the Imports (in Local Currency Unit) in Iceland in 2000 to that in 2002?
Your answer should be very brief. 0.96. What is the ratio of the Imports (in Local Currency Unit) of Senegal in 2000 to that in 2002?
Provide a succinct answer. 0.86. What is the ratio of the Imports (in Local Currency Unit) of Brunei Darussalam in 2001 to that in 2002?
Keep it short and to the point. 0.9. What is the ratio of the Imports (in Local Currency Unit) of Gambia, The in 2001 to that in 2002?
Give a very brief answer. 0.72. What is the ratio of the Imports (in Local Currency Unit) of Iceland in 2001 to that in 2002?
Offer a terse response. 1.05. What is the ratio of the Imports (in Local Currency Unit) of Senegal in 2001 to that in 2002?
Your response must be concise. 0.93. What is the difference between the highest and the second highest Imports (in Local Currency Unit) in Brunei Darussalam?
Keep it short and to the point. 1.59e+08. What is the difference between the highest and the second highest Imports (in Local Currency Unit) in Gambia, The?
Your answer should be very brief. 6.82e+08. What is the difference between the highest and the second highest Imports (in Local Currency Unit) of Iceland?
Your answer should be compact. 1.34e+1. What is the difference between the highest and the second highest Imports (in Local Currency Unit) in Senegal?
Ensure brevity in your answer.  9.83e+1. What is the difference between the highest and the lowest Imports (in Local Currency Unit) in Brunei Darussalam?
Your answer should be very brief. 8.08e+08. What is the difference between the highest and the lowest Imports (in Local Currency Unit) in Gambia, The?
Provide a succinct answer. 1.66e+09. What is the difference between the highest and the lowest Imports (in Local Currency Unit) in Iceland?
Provide a short and direct response. 1.15e+11. What is the difference between the highest and the lowest Imports (in Local Currency Unit) of Senegal?
Offer a terse response. 5.34e+11. 